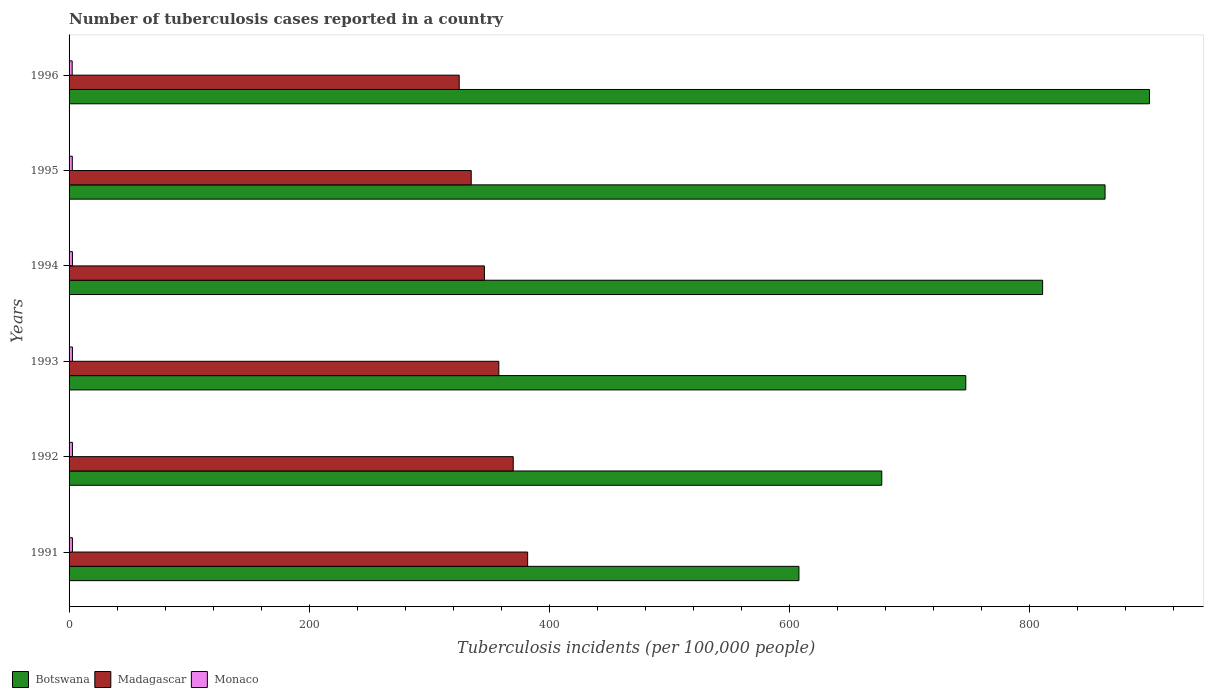How many groups of bars are there?
Offer a terse response. 6. Are the number of bars on each tick of the Y-axis equal?
Keep it short and to the point. Yes. How many bars are there on the 6th tick from the top?
Provide a succinct answer. 3. How many bars are there on the 2nd tick from the bottom?
Your answer should be very brief. 3. What is the label of the 5th group of bars from the top?
Provide a succinct answer. 1992. Across all years, what is the maximum number of tuberculosis cases reported in in Botswana?
Provide a short and direct response. 900. Across all years, what is the minimum number of tuberculosis cases reported in in Madagascar?
Ensure brevity in your answer.  325. In which year was the number of tuberculosis cases reported in in Madagascar minimum?
Your answer should be very brief. 1996. What is the total number of tuberculosis cases reported in in Botswana in the graph?
Make the answer very short. 4606. What is the difference between the number of tuberculosis cases reported in in Monaco in 1995 and that in 1996?
Provide a succinct answer. 0.1. What is the difference between the number of tuberculosis cases reported in in Botswana in 1993 and the number of tuberculosis cases reported in in Monaco in 1991?
Ensure brevity in your answer.  744.2. What is the average number of tuberculosis cases reported in in Botswana per year?
Ensure brevity in your answer.  767.67. In the year 1993, what is the difference between the number of tuberculosis cases reported in in Madagascar and number of tuberculosis cases reported in in Botswana?
Your answer should be compact. -389. What is the ratio of the number of tuberculosis cases reported in in Madagascar in 1994 to that in 1995?
Offer a terse response. 1.03. Is the number of tuberculosis cases reported in in Botswana in 1993 less than that in 1996?
Keep it short and to the point. Yes. What is the difference between the highest and the second highest number of tuberculosis cases reported in in Monaco?
Make the answer very short. 0. What is the difference between the highest and the lowest number of tuberculosis cases reported in in Madagascar?
Give a very brief answer. 57. In how many years, is the number of tuberculosis cases reported in in Botswana greater than the average number of tuberculosis cases reported in in Botswana taken over all years?
Keep it short and to the point. 3. Is the sum of the number of tuberculosis cases reported in in Botswana in 1994 and 1995 greater than the maximum number of tuberculosis cases reported in in Madagascar across all years?
Offer a very short reply. Yes. What does the 3rd bar from the top in 1991 represents?
Make the answer very short. Botswana. What does the 3rd bar from the bottom in 1993 represents?
Your response must be concise. Monaco. Is it the case that in every year, the sum of the number of tuberculosis cases reported in in Monaco and number of tuberculosis cases reported in in Madagascar is greater than the number of tuberculosis cases reported in in Botswana?
Your response must be concise. No. How many bars are there?
Your answer should be very brief. 18. Are all the bars in the graph horizontal?
Provide a succinct answer. Yes. What is the difference between two consecutive major ticks on the X-axis?
Offer a terse response. 200. Does the graph contain grids?
Your response must be concise. No. What is the title of the graph?
Ensure brevity in your answer.  Number of tuberculosis cases reported in a country. What is the label or title of the X-axis?
Offer a very short reply. Tuberculosis incidents (per 100,0 people). What is the Tuberculosis incidents (per 100,000 people) of Botswana in 1991?
Make the answer very short. 608. What is the Tuberculosis incidents (per 100,000 people) in Madagascar in 1991?
Keep it short and to the point. 382. What is the Tuberculosis incidents (per 100,000 people) in Botswana in 1992?
Give a very brief answer. 677. What is the Tuberculosis incidents (per 100,000 people) of Madagascar in 1992?
Keep it short and to the point. 370. What is the Tuberculosis incidents (per 100,000 people) of Monaco in 1992?
Your answer should be very brief. 2.8. What is the Tuberculosis incidents (per 100,000 people) of Botswana in 1993?
Offer a terse response. 747. What is the Tuberculosis incidents (per 100,000 people) in Madagascar in 1993?
Make the answer very short. 358. What is the Tuberculosis incidents (per 100,000 people) of Botswana in 1994?
Provide a short and direct response. 811. What is the Tuberculosis incidents (per 100,000 people) of Madagascar in 1994?
Provide a short and direct response. 346. What is the Tuberculosis incidents (per 100,000 people) in Monaco in 1994?
Give a very brief answer. 2.8. What is the Tuberculosis incidents (per 100,000 people) in Botswana in 1995?
Provide a succinct answer. 863. What is the Tuberculosis incidents (per 100,000 people) in Madagascar in 1995?
Your answer should be very brief. 335. What is the Tuberculosis incidents (per 100,000 people) in Botswana in 1996?
Your answer should be compact. 900. What is the Tuberculosis incidents (per 100,000 people) in Madagascar in 1996?
Your response must be concise. 325. What is the Tuberculosis incidents (per 100,000 people) in Monaco in 1996?
Ensure brevity in your answer.  2.6. Across all years, what is the maximum Tuberculosis incidents (per 100,000 people) in Botswana?
Offer a terse response. 900. Across all years, what is the maximum Tuberculosis incidents (per 100,000 people) of Madagascar?
Your response must be concise. 382. Across all years, what is the maximum Tuberculosis incidents (per 100,000 people) of Monaco?
Provide a succinct answer. 2.8. Across all years, what is the minimum Tuberculosis incidents (per 100,000 people) in Botswana?
Your response must be concise. 608. Across all years, what is the minimum Tuberculosis incidents (per 100,000 people) in Madagascar?
Make the answer very short. 325. Across all years, what is the minimum Tuberculosis incidents (per 100,000 people) of Monaco?
Ensure brevity in your answer.  2.6. What is the total Tuberculosis incidents (per 100,000 people) of Botswana in the graph?
Provide a short and direct response. 4606. What is the total Tuberculosis incidents (per 100,000 people) of Madagascar in the graph?
Your response must be concise. 2116. What is the difference between the Tuberculosis incidents (per 100,000 people) of Botswana in 1991 and that in 1992?
Give a very brief answer. -69. What is the difference between the Tuberculosis incidents (per 100,000 people) in Madagascar in 1991 and that in 1992?
Provide a short and direct response. 12. What is the difference between the Tuberculosis incidents (per 100,000 people) of Monaco in 1991 and that in 1992?
Make the answer very short. 0. What is the difference between the Tuberculosis incidents (per 100,000 people) in Botswana in 1991 and that in 1993?
Make the answer very short. -139. What is the difference between the Tuberculosis incidents (per 100,000 people) in Madagascar in 1991 and that in 1993?
Keep it short and to the point. 24. What is the difference between the Tuberculosis incidents (per 100,000 people) of Botswana in 1991 and that in 1994?
Your response must be concise. -203. What is the difference between the Tuberculosis incidents (per 100,000 people) in Madagascar in 1991 and that in 1994?
Make the answer very short. 36. What is the difference between the Tuberculosis incidents (per 100,000 people) in Botswana in 1991 and that in 1995?
Make the answer very short. -255. What is the difference between the Tuberculosis incidents (per 100,000 people) of Botswana in 1991 and that in 1996?
Offer a very short reply. -292. What is the difference between the Tuberculosis incidents (per 100,000 people) of Monaco in 1991 and that in 1996?
Make the answer very short. 0.2. What is the difference between the Tuberculosis incidents (per 100,000 people) of Botswana in 1992 and that in 1993?
Provide a succinct answer. -70. What is the difference between the Tuberculosis incidents (per 100,000 people) in Monaco in 1992 and that in 1993?
Your answer should be very brief. 0. What is the difference between the Tuberculosis incidents (per 100,000 people) in Botswana in 1992 and that in 1994?
Keep it short and to the point. -134. What is the difference between the Tuberculosis incidents (per 100,000 people) of Madagascar in 1992 and that in 1994?
Ensure brevity in your answer.  24. What is the difference between the Tuberculosis incidents (per 100,000 people) of Botswana in 1992 and that in 1995?
Provide a short and direct response. -186. What is the difference between the Tuberculosis incidents (per 100,000 people) in Monaco in 1992 and that in 1995?
Provide a succinct answer. 0.1. What is the difference between the Tuberculosis incidents (per 100,000 people) in Botswana in 1992 and that in 1996?
Keep it short and to the point. -223. What is the difference between the Tuberculosis incidents (per 100,000 people) in Madagascar in 1992 and that in 1996?
Offer a terse response. 45. What is the difference between the Tuberculosis incidents (per 100,000 people) of Monaco in 1992 and that in 1996?
Give a very brief answer. 0.2. What is the difference between the Tuberculosis incidents (per 100,000 people) of Botswana in 1993 and that in 1994?
Your answer should be very brief. -64. What is the difference between the Tuberculosis incidents (per 100,000 people) in Monaco in 1993 and that in 1994?
Give a very brief answer. 0. What is the difference between the Tuberculosis incidents (per 100,000 people) in Botswana in 1993 and that in 1995?
Your answer should be compact. -116. What is the difference between the Tuberculosis incidents (per 100,000 people) of Madagascar in 1993 and that in 1995?
Your answer should be compact. 23. What is the difference between the Tuberculosis incidents (per 100,000 people) of Botswana in 1993 and that in 1996?
Offer a terse response. -153. What is the difference between the Tuberculosis incidents (per 100,000 people) of Monaco in 1993 and that in 1996?
Your answer should be compact. 0.2. What is the difference between the Tuberculosis incidents (per 100,000 people) in Botswana in 1994 and that in 1995?
Your response must be concise. -52. What is the difference between the Tuberculosis incidents (per 100,000 people) of Madagascar in 1994 and that in 1995?
Ensure brevity in your answer.  11. What is the difference between the Tuberculosis incidents (per 100,000 people) in Monaco in 1994 and that in 1995?
Your answer should be very brief. 0.1. What is the difference between the Tuberculosis incidents (per 100,000 people) of Botswana in 1994 and that in 1996?
Make the answer very short. -89. What is the difference between the Tuberculosis incidents (per 100,000 people) of Botswana in 1995 and that in 1996?
Provide a succinct answer. -37. What is the difference between the Tuberculosis incidents (per 100,000 people) in Botswana in 1991 and the Tuberculosis incidents (per 100,000 people) in Madagascar in 1992?
Your answer should be compact. 238. What is the difference between the Tuberculosis incidents (per 100,000 people) in Botswana in 1991 and the Tuberculosis incidents (per 100,000 people) in Monaco in 1992?
Ensure brevity in your answer.  605.2. What is the difference between the Tuberculosis incidents (per 100,000 people) of Madagascar in 1991 and the Tuberculosis incidents (per 100,000 people) of Monaco in 1992?
Keep it short and to the point. 379.2. What is the difference between the Tuberculosis incidents (per 100,000 people) of Botswana in 1991 and the Tuberculosis incidents (per 100,000 people) of Madagascar in 1993?
Provide a short and direct response. 250. What is the difference between the Tuberculosis incidents (per 100,000 people) of Botswana in 1991 and the Tuberculosis incidents (per 100,000 people) of Monaco in 1993?
Provide a short and direct response. 605.2. What is the difference between the Tuberculosis incidents (per 100,000 people) in Madagascar in 1991 and the Tuberculosis incidents (per 100,000 people) in Monaco in 1993?
Your response must be concise. 379.2. What is the difference between the Tuberculosis incidents (per 100,000 people) in Botswana in 1991 and the Tuberculosis incidents (per 100,000 people) in Madagascar in 1994?
Offer a terse response. 262. What is the difference between the Tuberculosis incidents (per 100,000 people) of Botswana in 1991 and the Tuberculosis incidents (per 100,000 people) of Monaco in 1994?
Your answer should be compact. 605.2. What is the difference between the Tuberculosis incidents (per 100,000 people) in Madagascar in 1991 and the Tuberculosis incidents (per 100,000 people) in Monaco in 1994?
Your response must be concise. 379.2. What is the difference between the Tuberculosis incidents (per 100,000 people) in Botswana in 1991 and the Tuberculosis incidents (per 100,000 people) in Madagascar in 1995?
Your response must be concise. 273. What is the difference between the Tuberculosis incidents (per 100,000 people) in Botswana in 1991 and the Tuberculosis incidents (per 100,000 people) in Monaco in 1995?
Provide a succinct answer. 605.3. What is the difference between the Tuberculosis incidents (per 100,000 people) of Madagascar in 1991 and the Tuberculosis incidents (per 100,000 people) of Monaco in 1995?
Your answer should be very brief. 379.3. What is the difference between the Tuberculosis incidents (per 100,000 people) of Botswana in 1991 and the Tuberculosis incidents (per 100,000 people) of Madagascar in 1996?
Offer a terse response. 283. What is the difference between the Tuberculosis incidents (per 100,000 people) in Botswana in 1991 and the Tuberculosis incidents (per 100,000 people) in Monaco in 1996?
Your response must be concise. 605.4. What is the difference between the Tuberculosis incidents (per 100,000 people) in Madagascar in 1991 and the Tuberculosis incidents (per 100,000 people) in Monaco in 1996?
Your response must be concise. 379.4. What is the difference between the Tuberculosis incidents (per 100,000 people) in Botswana in 1992 and the Tuberculosis incidents (per 100,000 people) in Madagascar in 1993?
Ensure brevity in your answer.  319. What is the difference between the Tuberculosis incidents (per 100,000 people) in Botswana in 1992 and the Tuberculosis incidents (per 100,000 people) in Monaco in 1993?
Keep it short and to the point. 674.2. What is the difference between the Tuberculosis incidents (per 100,000 people) of Madagascar in 1992 and the Tuberculosis incidents (per 100,000 people) of Monaco in 1993?
Make the answer very short. 367.2. What is the difference between the Tuberculosis incidents (per 100,000 people) of Botswana in 1992 and the Tuberculosis incidents (per 100,000 people) of Madagascar in 1994?
Ensure brevity in your answer.  331. What is the difference between the Tuberculosis incidents (per 100,000 people) of Botswana in 1992 and the Tuberculosis incidents (per 100,000 people) of Monaco in 1994?
Keep it short and to the point. 674.2. What is the difference between the Tuberculosis incidents (per 100,000 people) of Madagascar in 1992 and the Tuberculosis incidents (per 100,000 people) of Monaco in 1994?
Provide a succinct answer. 367.2. What is the difference between the Tuberculosis incidents (per 100,000 people) in Botswana in 1992 and the Tuberculosis incidents (per 100,000 people) in Madagascar in 1995?
Offer a very short reply. 342. What is the difference between the Tuberculosis incidents (per 100,000 people) of Botswana in 1992 and the Tuberculosis incidents (per 100,000 people) of Monaco in 1995?
Make the answer very short. 674.3. What is the difference between the Tuberculosis incidents (per 100,000 people) of Madagascar in 1992 and the Tuberculosis incidents (per 100,000 people) of Monaco in 1995?
Make the answer very short. 367.3. What is the difference between the Tuberculosis incidents (per 100,000 people) of Botswana in 1992 and the Tuberculosis incidents (per 100,000 people) of Madagascar in 1996?
Your answer should be compact. 352. What is the difference between the Tuberculosis incidents (per 100,000 people) of Botswana in 1992 and the Tuberculosis incidents (per 100,000 people) of Monaco in 1996?
Offer a very short reply. 674.4. What is the difference between the Tuberculosis incidents (per 100,000 people) of Madagascar in 1992 and the Tuberculosis incidents (per 100,000 people) of Monaco in 1996?
Ensure brevity in your answer.  367.4. What is the difference between the Tuberculosis incidents (per 100,000 people) of Botswana in 1993 and the Tuberculosis incidents (per 100,000 people) of Madagascar in 1994?
Provide a short and direct response. 401. What is the difference between the Tuberculosis incidents (per 100,000 people) of Botswana in 1993 and the Tuberculosis incidents (per 100,000 people) of Monaco in 1994?
Give a very brief answer. 744.2. What is the difference between the Tuberculosis incidents (per 100,000 people) of Madagascar in 1993 and the Tuberculosis incidents (per 100,000 people) of Monaco in 1994?
Your answer should be compact. 355.2. What is the difference between the Tuberculosis incidents (per 100,000 people) in Botswana in 1993 and the Tuberculosis incidents (per 100,000 people) in Madagascar in 1995?
Offer a terse response. 412. What is the difference between the Tuberculosis incidents (per 100,000 people) in Botswana in 1993 and the Tuberculosis incidents (per 100,000 people) in Monaco in 1995?
Give a very brief answer. 744.3. What is the difference between the Tuberculosis incidents (per 100,000 people) in Madagascar in 1993 and the Tuberculosis incidents (per 100,000 people) in Monaco in 1995?
Your answer should be compact. 355.3. What is the difference between the Tuberculosis incidents (per 100,000 people) in Botswana in 1993 and the Tuberculosis incidents (per 100,000 people) in Madagascar in 1996?
Give a very brief answer. 422. What is the difference between the Tuberculosis incidents (per 100,000 people) in Botswana in 1993 and the Tuberculosis incidents (per 100,000 people) in Monaco in 1996?
Provide a succinct answer. 744.4. What is the difference between the Tuberculosis incidents (per 100,000 people) of Madagascar in 1993 and the Tuberculosis incidents (per 100,000 people) of Monaco in 1996?
Offer a terse response. 355.4. What is the difference between the Tuberculosis incidents (per 100,000 people) of Botswana in 1994 and the Tuberculosis incidents (per 100,000 people) of Madagascar in 1995?
Provide a succinct answer. 476. What is the difference between the Tuberculosis incidents (per 100,000 people) in Botswana in 1994 and the Tuberculosis incidents (per 100,000 people) in Monaco in 1995?
Your response must be concise. 808.3. What is the difference between the Tuberculosis incidents (per 100,000 people) of Madagascar in 1994 and the Tuberculosis incidents (per 100,000 people) of Monaco in 1995?
Ensure brevity in your answer.  343.3. What is the difference between the Tuberculosis incidents (per 100,000 people) of Botswana in 1994 and the Tuberculosis incidents (per 100,000 people) of Madagascar in 1996?
Offer a terse response. 486. What is the difference between the Tuberculosis incidents (per 100,000 people) of Botswana in 1994 and the Tuberculosis incidents (per 100,000 people) of Monaco in 1996?
Give a very brief answer. 808.4. What is the difference between the Tuberculosis incidents (per 100,000 people) in Madagascar in 1994 and the Tuberculosis incidents (per 100,000 people) in Monaco in 1996?
Ensure brevity in your answer.  343.4. What is the difference between the Tuberculosis incidents (per 100,000 people) of Botswana in 1995 and the Tuberculosis incidents (per 100,000 people) of Madagascar in 1996?
Keep it short and to the point. 538. What is the difference between the Tuberculosis incidents (per 100,000 people) in Botswana in 1995 and the Tuberculosis incidents (per 100,000 people) in Monaco in 1996?
Your answer should be very brief. 860.4. What is the difference between the Tuberculosis incidents (per 100,000 people) of Madagascar in 1995 and the Tuberculosis incidents (per 100,000 people) of Monaco in 1996?
Make the answer very short. 332.4. What is the average Tuberculosis incidents (per 100,000 people) in Botswana per year?
Your answer should be compact. 767.67. What is the average Tuberculosis incidents (per 100,000 people) in Madagascar per year?
Your answer should be very brief. 352.67. What is the average Tuberculosis incidents (per 100,000 people) of Monaco per year?
Provide a succinct answer. 2.75. In the year 1991, what is the difference between the Tuberculosis incidents (per 100,000 people) in Botswana and Tuberculosis incidents (per 100,000 people) in Madagascar?
Give a very brief answer. 226. In the year 1991, what is the difference between the Tuberculosis incidents (per 100,000 people) of Botswana and Tuberculosis incidents (per 100,000 people) of Monaco?
Your answer should be compact. 605.2. In the year 1991, what is the difference between the Tuberculosis incidents (per 100,000 people) of Madagascar and Tuberculosis incidents (per 100,000 people) of Monaco?
Your response must be concise. 379.2. In the year 1992, what is the difference between the Tuberculosis incidents (per 100,000 people) in Botswana and Tuberculosis incidents (per 100,000 people) in Madagascar?
Your response must be concise. 307. In the year 1992, what is the difference between the Tuberculosis incidents (per 100,000 people) in Botswana and Tuberculosis incidents (per 100,000 people) in Monaco?
Offer a very short reply. 674.2. In the year 1992, what is the difference between the Tuberculosis incidents (per 100,000 people) of Madagascar and Tuberculosis incidents (per 100,000 people) of Monaco?
Provide a short and direct response. 367.2. In the year 1993, what is the difference between the Tuberculosis incidents (per 100,000 people) in Botswana and Tuberculosis incidents (per 100,000 people) in Madagascar?
Your answer should be very brief. 389. In the year 1993, what is the difference between the Tuberculosis incidents (per 100,000 people) of Botswana and Tuberculosis incidents (per 100,000 people) of Monaco?
Offer a terse response. 744.2. In the year 1993, what is the difference between the Tuberculosis incidents (per 100,000 people) in Madagascar and Tuberculosis incidents (per 100,000 people) in Monaco?
Provide a succinct answer. 355.2. In the year 1994, what is the difference between the Tuberculosis incidents (per 100,000 people) in Botswana and Tuberculosis incidents (per 100,000 people) in Madagascar?
Give a very brief answer. 465. In the year 1994, what is the difference between the Tuberculosis incidents (per 100,000 people) in Botswana and Tuberculosis incidents (per 100,000 people) in Monaco?
Give a very brief answer. 808.2. In the year 1994, what is the difference between the Tuberculosis incidents (per 100,000 people) of Madagascar and Tuberculosis incidents (per 100,000 people) of Monaco?
Offer a very short reply. 343.2. In the year 1995, what is the difference between the Tuberculosis incidents (per 100,000 people) in Botswana and Tuberculosis incidents (per 100,000 people) in Madagascar?
Offer a very short reply. 528. In the year 1995, what is the difference between the Tuberculosis incidents (per 100,000 people) of Botswana and Tuberculosis incidents (per 100,000 people) of Monaco?
Provide a short and direct response. 860.3. In the year 1995, what is the difference between the Tuberculosis incidents (per 100,000 people) of Madagascar and Tuberculosis incidents (per 100,000 people) of Monaco?
Provide a succinct answer. 332.3. In the year 1996, what is the difference between the Tuberculosis incidents (per 100,000 people) of Botswana and Tuberculosis incidents (per 100,000 people) of Madagascar?
Provide a succinct answer. 575. In the year 1996, what is the difference between the Tuberculosis incidents (per 100,000 people) in Botswana and Tuberculosis incidents (per 100,000 people) in Monaco?
Keep it short and to the point. 897.4. In the year 1996, what is the difference between the Tuberculosis incidents (per 100,000 people) of Madagascar and Tuberculosis incidents (per 100,000 people) of Monaco?
Provide a short and direct response. 322.4. What is the ratio of the Tuberculosis incidents (per 100,000 people) of Botswana in 1991 to that in 1992?
Your response must be concise. 0.9. What is the ratio of the Tuberculosis incidents (per 100,000 people) in Madagascar in 1991 to that in 1992?
Offer a terse response. 1.03. What is the ratio of the Tuberculosis incidents (per 100,000 people) of Monaco in 1991 to that in 1992?
Ensure brevity in your answer.  1. What is the ratio of the Tuberculosis incidents (per 100,000 people) in Botswana in 1991 to that in 1993?
Provide a short and direct response. 0.81. What is the ratio of the Tuberculosis incidents (per 100,000 people) of Madagascar in 1991 to that in 1993?
Provide a succinct answer. 1.07. What is the ratio of the Tuberculosis incidents (per 100,000 people) of Botswana in 1991 to that in 1994?
Ensure brevity in your answer.  0.75. What is the ratio of the Tuberculosis incidents (per 100,000 people) of Madagascar in 1991 to that in 1994?
Offer a very short reply. 1.1. What is the ratio of the Tuberculosis incidents (per 100,000 people) of Monaco in 1991 to that in 1994?
Offer a very short reply. 1. What is the ratio of the Tuberculosis incidents (per 100,000 people) in Botswana in 1991 to that in 1995?
Provide a short and direct response. 0.7. What is the ratio of the Tuberculosis incidents (per 100,000 people) of Madagascar in 1991 to that in 1995?
Your answer should be compact. 1.14. What is the ratio of the Tuberculosis incidents (per 100,000 people) in Botswana in 1991 to that in 1996?
Provide a succinct answer. 0.68. What is the ratio of the Tuberculosis incidents (per 100,000 people) of Madagascar in 1991 to that in 1996?
Keep it short and to the point. 1.18. What is the ratio of the Tuberculosis incidents (per 100,000 people) of Monaco in 1991 to that in 1996?
Offer a terse response. 1.08. What is the ratio of the Tuberculosis incidents (per 100,000 people) in Botswana in 1992 to that in 1993?
Ensure brevity in your answer.  0.91. What is the ratio of the Tuberculosis incidents (per 100,000 people) in Madagascar in 1992 to that in 1993?
Provide a short and direct response. 1.03. What is the ratio of the Tuberculosis incidents (per 100,000 people) of Botswana in 1992 to that in 1994?
Offer a terse response. 0.83. What is the ratio of the Tuberculosis incidents (per 100,000 people) in Madagascar in 1992 to that in 1994?
Give a very brief answer. 1.07. What is the ratio of the Tuberculosis incidents (per 100,000 people) of Monaco in 1992 to that in 1994?
Your answer should be very brief. 1. What is the ratio of the Tuberculosis incidents (per 100,000 people) of Botswana in 1992 to that in 1995?
Your answer should be very brief. 0.78. What is the ratio of the Tuberculosis incidents (per 100,000 people) in Madagascar in 1992 to that in 1995?
Your answer should be very brief. 1.1. What is the ratio of the Tuberculosis incidents (per 100,000 people) in Botswana in 1992 to that in 1996?
Provide a succinct answer. 0.75. What is the ratio of the Tuberculosis incidents (per 100,000 people) of Madagascar in 1992 to that in 1996?
Your answer should be compact. 1.14. What is the ratio of the Tuberculosis incidents (per 100,000 people) of Monaco in 1992 to that in 1996?
Offer a terse response. 1.08. What is the ratio of the Tuberculosis incidents (per 100,000 people) in Botswana in 1993 to that in 1994?
Provide a succinct answer. 0.92. What is the ratio of the Tuberculosis incidents (per 100,000 people) in Madagascar in 1993 to that in 1994?
Keep it short and to the point. 1.03. What is the ratio of the Tuberculosis incidents (per 100,000 people) of Monaco in 1993 to that in 1994?
Give a very brief answer. 1. What is the ratio of the Tuberculosis incidents (per 100,000 people) of Botswana in 1993 to that in 1995?
Your answer should be very brief. 0.87. What is the ratio of the Tuberculosis incidents (per 100,000 people) in Madagascar in 1993 to that in 1995?
Offer a terse response. 1.07. What is the ratio of the Tuberculosis incidents (per 100,000 people) of Botswana in 1993 to that in 1996?
Your response must be concise. 0.83. What is the ratio of the Tuberculosis incidents (per 100,000 people) in Madagascar in 1993 to that in 1996?
Provide a short and direct response. 1.1. What is the ratio of the Tuberculosis incidents (per 100,000 people) in Botswana in 1994 to that in 1995?
Make the answer very short. 0.94. What is the ratio of the Tuberculosis incidents (per 100,000 people) of Madagascar in 1994 to that in 1995?
Provide a succinct answer. 1.03. What is the ratio of the Tuberculosis incidents (per 100,000 people) of Botswana in 1994 to that in 1996?
Make the answer very short. 0.9. What is the ratio of the Tuberculosis incidents (per 100,000 people) of Madagascar in 1994 to that in 1996?
Keep it short and to the point. 1.06. What is the ratio of the Tuberculosis incidents (per 100,000 people) of Botswana in 1995 to that in 1996?
Give a very brief answer. 0.96. What is the ratio of the Tuberculosis incidents (per 100,000 people) in Madagascar in 1995 to that in 1996?
Offer a very short reply. 1.03. What is the ratio of the Tuberculosis incidents (per 100,000 people) in Monaco in 1995 to that in 1996?
Provide a succinct answer. 1.04. What is the difference between the highest and the second highest Tuberculosis incidents (per 100,000 people) of Monaco?
Give a very brief answer. 0. What is the difference between the highest and the lowest Tuberculosis incidents (per 100,000 people) of Botswana?
Make the answer very short. 292. 